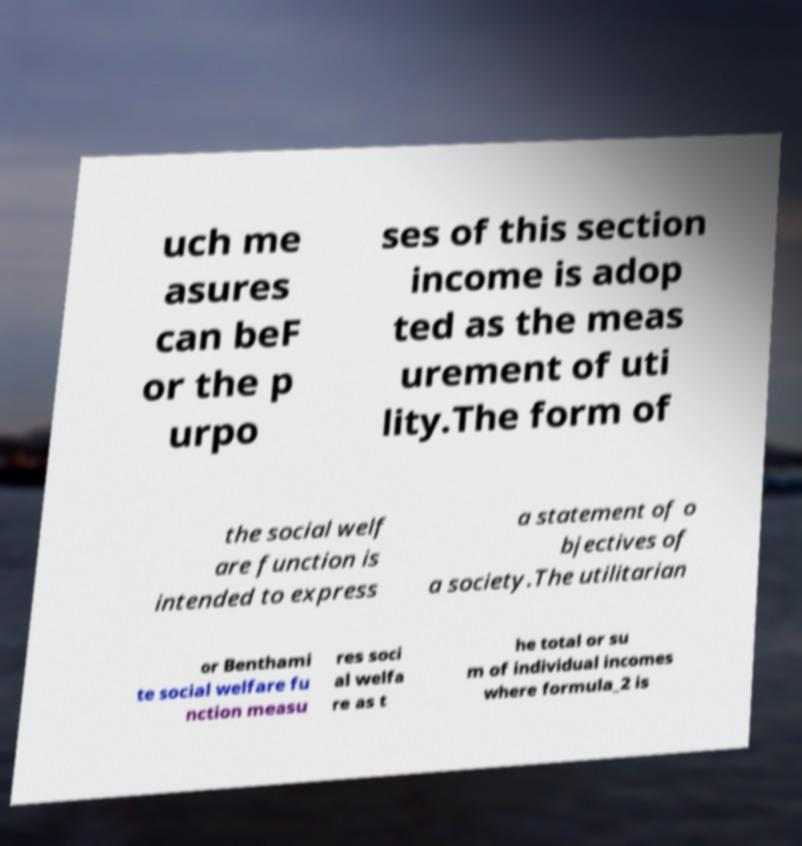Could you assist in decoding the text presented in this image and type it out clearly? uch me asures can beF or the p urpo ses of this section income is adop ted as the meas urement of uti lity.The form of the social welf are function is intended to express a statement of o bjectives of a society.The utilitarian or Benthami te social welfare fu nction measu res soci al welfa re as t he total or su m of individual incomes where formula_2 is 